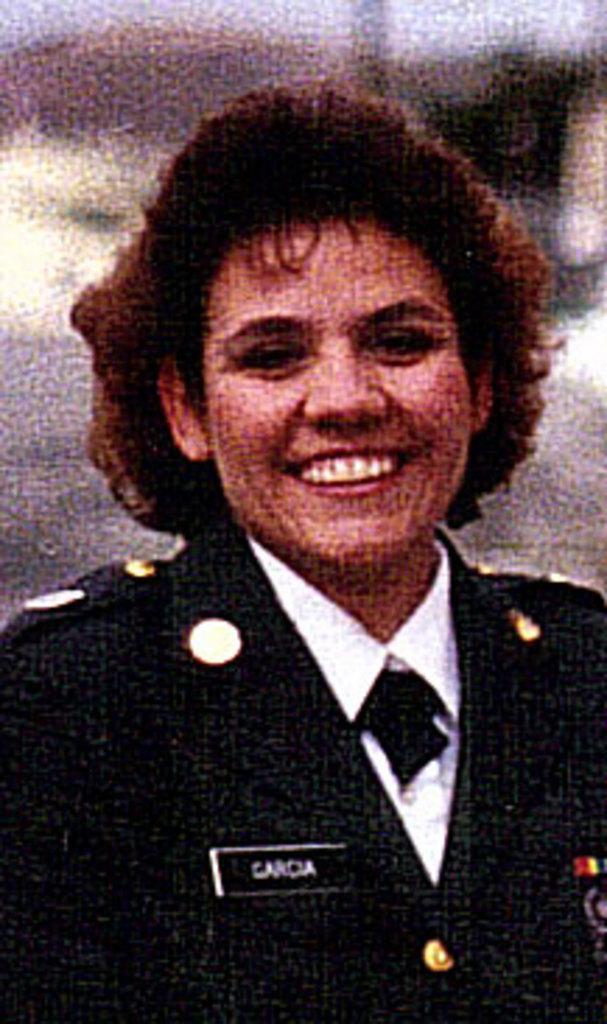How would you summarize this image in a sentence or two? In this image as we can see there is one women standing and wearing a black color dress in middle of this image. 